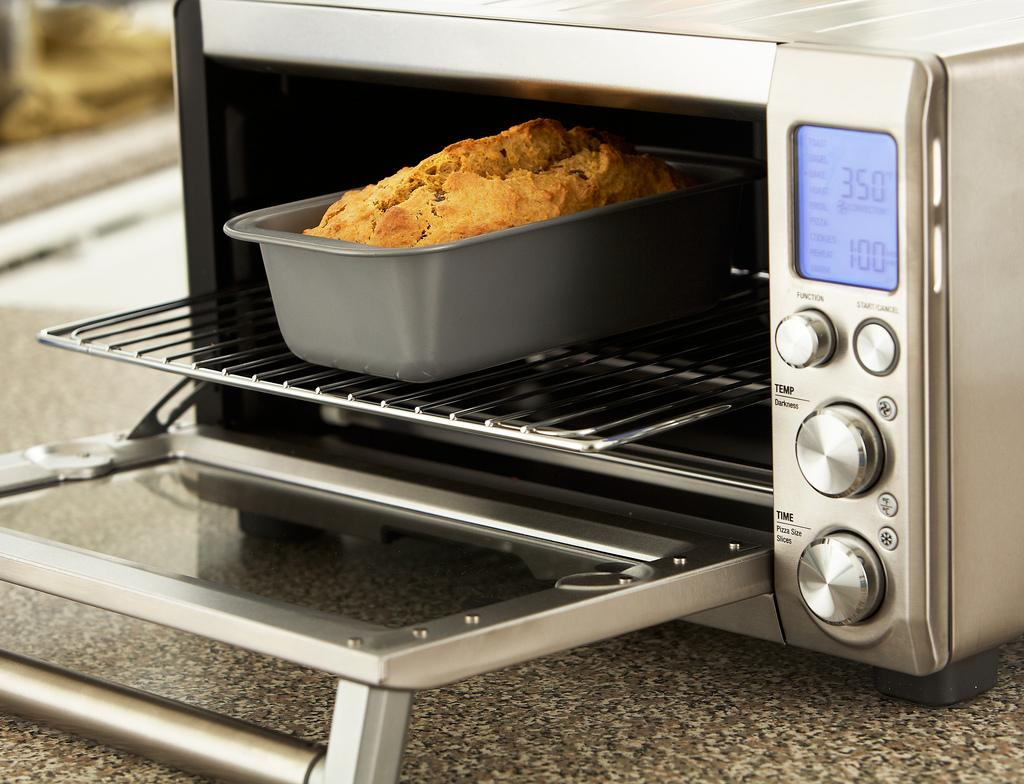<image>
Summarize the visual content of the image. Some bread in a silver microwave, the silver microwave says 350 on it. 